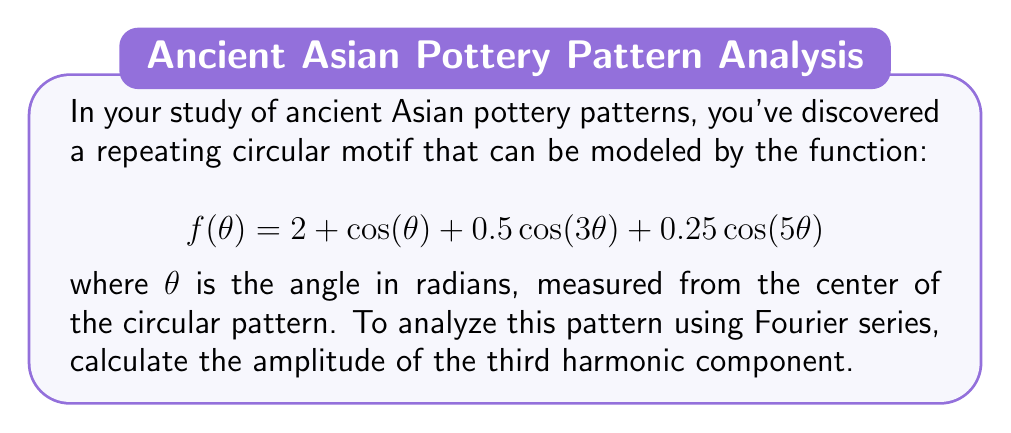Provide a solution to this math problem. To solve this problem, we need to understand the structure of a Fourier series and identify the components in the given function. A general Fourier series can be expressed as:

$$f(\theta) = a_0 + \sum_{n=1}^{\infty} [a_n \cos(n\theta) + b_n \sin(n\theta)]$$

Where:
- $a_0$ is the constant term (DC component)
- $a_n$ are the amplitudes of the cosine terms
- $b_n$ are the amplitudes of the sine terms

In our given function:

$$f(\theta) = 2 + \cos(\theta) + 0.5\cos(3\theta) + 0.25\cos(5\theta)$$

We can identify:
1. $a_0 = 2$ (the constant term)
2. $a_1 = 1$ (coefficient of $\cos(\theta)$)
3. $a_3 = 0.5$ (coefficient of $\cos(3\theta)$)
4. $a_5 = 0.25$ (coefficient of $\cos(5\theta)$)

All other $a_n$ and all $b_n$ are zero.

The question asks for the amplitude of the third harmonic component. In Fourier analysis, the nth harmonic refers to the terms with frequency n times the fundamental frequency. Here, the third harmonic is represented by $\cos(3\theta)$.

The amplitude of this component is the absolute value of its coefficient, which is $|a_3| = |0.5| = 0.5$.
Answer: The amplitude of the third harmonic component is 0.5. 